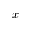Convert formula to latex. <formula><loc_0><loc_0><loc_500><loc_500>x</formula> 